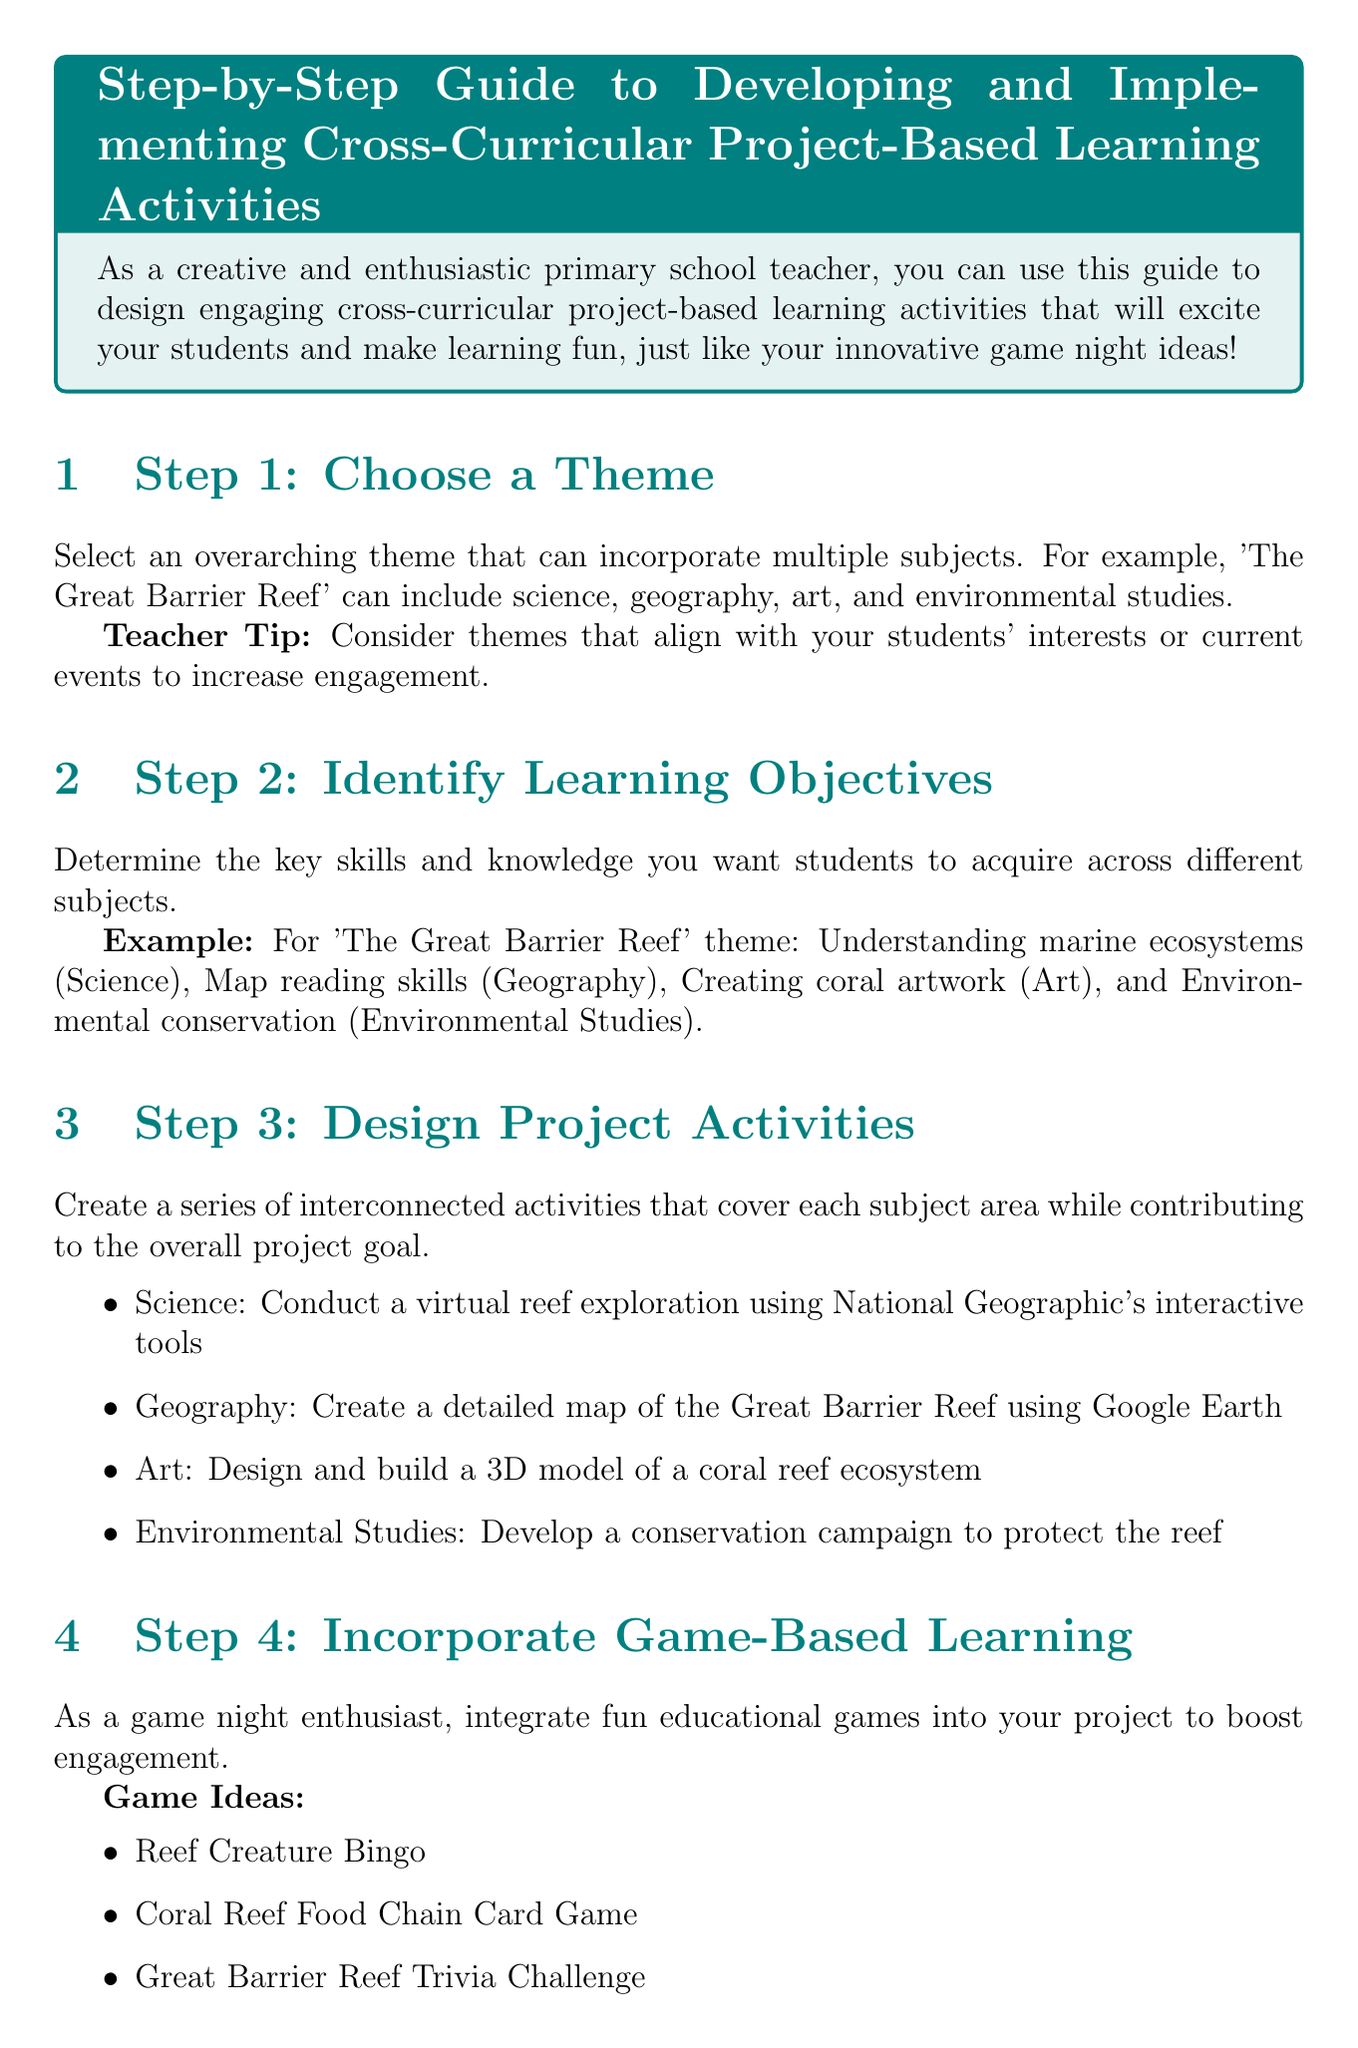What is the overarching theme suggested in Step 1? The theme is a central idea that can involve multiple subjects, such as 'The Great Barrier Reef'.
Answer: The Great Barrier Reef What subjects are included in the theme example? The example includes subjects that can be integrated into the theme, such as science, geography, art, and environmental studies.
Answer: Science, geography, art, environmental studies What is the timeline allocation for Week 2? Week 2 is dedicated to the activities associated with geography and science.
Answer: Geography and Science activities List one game idea mentioned in Step 4. The guide suggests specific game ideas to incorporate into the project for enhanced engagement.
Answer: Reef Creature Bingo What is one method for assessing student learning outcomes? The document outlines several methods for evaluation, focusing on different aspects of student performance.
Answer: Project portfolio What is the main purpose of Step 9? Reflecting is important to gather insights that inform improvements for future projects.
Answer: Gather feedback What type of skills does Step 2 mention for students to acquire? This step emphasizes the importance of determining essential skills and knowledge across subject areas.
Answer: Key skills and knowledge How many steps are mentioned in the guide? The total count of steps provides an overview of the project-based learning process outlined in the document.
Answer: Nine steps 